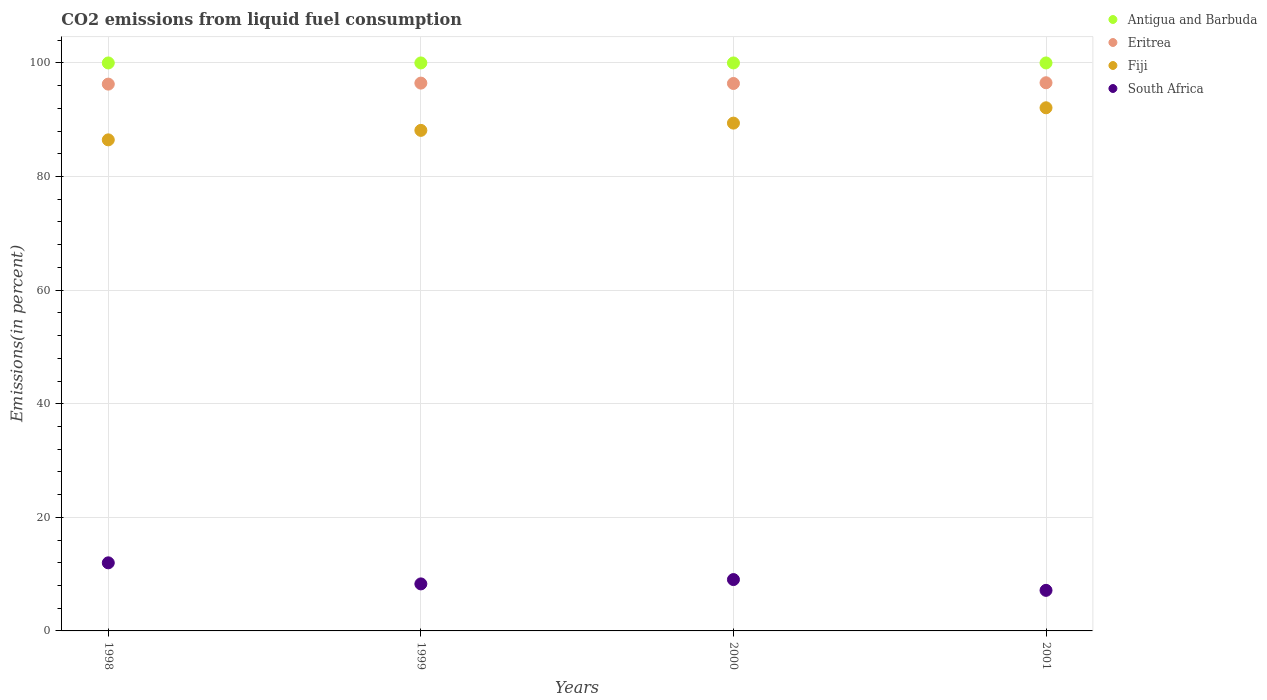Is the number of dotlines equal to the number of legend labels?
Make the answer very short. Yes. What is the total CO2 emitted in South Africa in 2000?
Your answer should be compact. 9.04. Across all years, what is the maximum total CO2 emitted in Antigua and Barbuda?
Your response must be concise. 100. Across all years, what is the minimum total CO2 emitted in Eritrea?
Give a very brief answer. 96.27. In which year was the total CO2 emitted in Eritrea maximum?
Keep it short and to the point. 2001. What is the total total CO2 emitted in Antigua and Barbuda in the graph?
Your answer should be very brief. 400. What is the difference between the total CO2 emitted in Antigua and Barbuda in 1998 and that in 2001?
Provide a short and direct response. 0. What is the difference between the total CO2 emitted in Eritrea in 1998 and the total CO2 emitted in Fiji in 1999?
Provide a succinct answer. 8.15. What is the average total CO2 emitted in Eritrea per year?
Your answer should be very brief. 96.41. In the year 2000, what is the difference between the total CO2 emitted in Eritrea and total CO2 emitted in Antigua and Barbuda?
Your response must be concise. -3.61. In how many years, is the total CO2 emitted in Fiji greater than 88 %?
Your answer should be compact. 3. What is the ratio of the total CO2 emitted in Eritrea in 1998 to that in 2000?
Make the answer very short. 1. What is the difference between the highest and the second highest total CO2 emitted in Fiji?
Make the answer very short. 2.7. In how many years, is the total CO2 emitted in Fiji greater than the average total CO2 emitted in Fiji taken over all years?
Your answer should be very brief. 2. Does the total CO2 emitted in Antigua and Barbuda monotonically increase over the years?
Provide a succinct answer. No. How many years are there in the graph?
Your answer should be compact. 4. Does the graph contain any zero values?
Your response must be concise. No. Does the graph contain grids?
Give a very brief answer. Yes. Where does the legend appear in the graph?
Keep it short and to the point. Top right. How many legend labels are there?
Provide a short and direct response. 4. What is the title of the graph?
Provide a succinct answer. CO2 emissions from liquid fuel consumption. Does "Korea (Republic)" appear as one of the legend labels in the graph?
Your response must be concise. No. What is the label or title of the Y-axis?
Your response must be concise. Emissions(in percent). What is the Emissions(in percent) in Antigua and Barbuda in 1998?
Offer a very short reply. 100. What is the Emissions(in percent) of Eritrea in 1998?
Ensure brevity in your answer.  96.27. What is the Emissions(in percent) in Fiji in 1998?
Give a very brief answer. 86.46. What is the Emissions(in percent) in South Africa in 1998?
Offer a terse response. 11.99. What is the Emissions(in percent) in Antigua and Barbuda in 1999?
Provide a succinct answer. 100. What is the Emissions(in percent) in Eritrea in 1999?
Ensure brevity in your answer.  96.45. What is the Emissions(in percent) of Fiji in 1999?
Your response must be concise. 88.13. What is the Emissions(in percent) in South Africa in 1999?
Your answer should be very brief. 8.28. What is the Emissions(in percent) of Eritrea in 2000?
Offer a very short reply. 96.39. What is the Emissions(in percent) in Fiji in 2000?
Offer a very short reply. 89.41. What is the Emissions(in percent) of South Africa in 2000?
Provide a short and direct response. 9.04. What is the Emissions(in percent) of Antigua and Barbuda in 2001?
Ensure brevity in your answer.  100. What is the Emissions(in percent) in Eritrea in 2001?
Ensure brevity in your answer.  96.51. What is the Emissions(in percent) in Fiji in 2001?
Provide a succinct answer. 92.11. What is the Emissions(in percent) in South Africa in 2001?
Ensure brevity in your answer.  7.14. Across all years, what is the maximum Emissions(in percent) in Eritrea?
Make the answer very short. 96.51. Across all years, what is the maximum Emissions(in percent) in Fiji?
Provide a succinct answer. 92.11. Across all years, what is the maximum Emissions(in percent) in South Africa?
Provide a succinct answer. 11.99. Across all years, what is the minimum Emissions(in percent) of Eritrea?
Provide a succinct answer. 96.27. Across all years, what is the minimum Emissions(in percent) in Fiji?
Ensure brevity in your answer.  86.46. Across all years, what is the minimum Emissions(in percent) of South Africa?
Give a very brief answer. 7.14. What is the total Emissions(in percent) of Antigua and Barbuda in the graph?
Provide a short and direct response. 400. What is the total Emissions(in percent) of Eritrea in the graph?
Offer a terse response. 385.62. What is the total Emissions(in percent) in Fiji in the graph?
Give a very brief answer. 356.1. What is the total Emissions(in percent) of South Africa in the graph?
Your response must be concise. 36.45. What is the difference between the Emissions(in percent) of Eritrea in 1998 and that in 1999?
Offer a very short reply. -0.18. What is the difference between the Emissions(in percent) in Fiji in 1998 and that in 1999?
Make the answer very short. -1.67. What is the difference between the Emissions(in percent) of South Africa in 1998 and that in 1999?
Your response must be concise. 3.71. What is the difference between the Emissions(in percent) in Antigua and Barbuda in 1998 and that in 2000?
Give a very brief answer. 0. What is the difference between the Emissions(in percent) in Eritrea in 1998 and that in 2000?
Your answer should be compact. -0.11. What is the difference between the Emissions(in percent) in Fiji in 1998 and that in 2000?
Keep it short and to the point. -2.95. What is the difference between the Emissions(in percent) in South Africa in 1998 and that in 2000?
Your response must be concise. 2.95. What is the difference between the Emissions(in percent) in Antigua and Barbuda in 1998 and that in 2001?
Your answer should be compact. 0. What is the difference between the Emissions(in percent) of Eritrea in 1998 and that in 2001?
Your answer should be very brief. -0.24. What is the difference between the Emissions(in percent) of Fiji in 1998 and that in 2001?
Your answer should be very brief. -5.65. What is the difference between the Emissions(in percent) in South Africa in 1998 and that in 2001?
Your answer should be compact. 4.85. What is the difference between the Emissions(in percent) of Antigua and Barbuda in 1999 and that in 2000?
Give a very brief answer. 0. What is the difference between the Emissions(in percent) in Eritrea in 1999 and that in 2000?
Give a very brief answer. 0.06. What is the difference between the Emissions(in percent) in Fiji in 1999 and that in 2000?
Offer a terse response. -1.28. What is the difference between the Emissions(in percent) of South Africa in 1999 and that in 2000?
Your answer should be very brief. -0.76. What is the difference between the Emissions(in percent) in Antigua and Barbuda in 1999 and that in 2001?
Provide a short and direct response. 0. What is the difference between the Emissions(in percent) of Eritrea in 1999 and that in 2001?
Provide a succinct answer. -0.06. What is the difference between the Emissions(in percent) of Fiji in 1999 and that in 2001?
Offer a terse response. -3.98. What is the difference between the Emissions(in percent) in South Africa in 1999 and that in 2001?
Give a very brief answer. 1.14. What is the difference between the Emissions(in percent) in Antigua and Barbuda in 2000 and that in 2001?
Ensure brevity in your answer.  0. What is the difference between the Emissions(in percent) of Eritrea in 2000 and that in 2001?
Your response must be concise. -0.13. What is the difference between the Emissions(in percent) of Fiji in 2000 and that in 2001?
Keep it short and to the point. -2.7. What is the difference between the Emissions(in percent) of South Africa in 2000 and that in 2001?
Give a very brief answer. 1.9. What is the difference between the Emissions(in percent) in Antigua and Barbuda in 1998 and the Emissions(in percent) in Eritrea in 1999?
Your answer should be compact. 3.55. What is the difference between the Emissions(in percent) of Antigua and Barbuda in 1998 and the Emissions(in percent) of Fiji in 1999?
Keep it short and to the point. 11.87. What is the difference between the Emissions(in percent) of Antigua and Barbuda in 1998 and the Emissions(in percent) of South Africa in 1999?
Ensure brevity in your answer.  91.72. What is the difference between the Emissions(in percent) of Eritrea in 1998 and the Emissions(in percent) of Fiji in 1999?
Ensure brevity in your answer.  8.15. What is the difference between the Emissions(in percent) in Eritrea in 1998 and the Emissions(in percent) in South Africa in 1999?
Provide a succinct answer. 88. What is the difference between the Emissions(in percent) of Fiji in 1998 and the Emissions(in percent) of South Africa in 1999?
Provide a short and direct response. 78.18. What is the difference between the Emissions(in percent) of Antigua and Barbuda in 1998 and the Emissions(in percent) of Eritrea in 2000?
Give a very brief answer. 3.61. What is the difference between the Emissions(in percent) of Antigua and Barbuda in 1998 and the Emissions(in percent) of Fiji in 2000?
Provide a short and direct response. 10.59. What is the difference between the Emissions(in percent) of Antigua and Barbuda in 1998 and the Emissions(in percent) of South Africa in 2000?
Provide a short and direct response. 90.96. What is the difference between the Emissions(in percent) in Eritrea in 1998 and the Emissions(in percent) in Fiji in 2000?
Ensure brevity in your answer.  6.87. What is the difference between the Emissions(in percent) in Eritrea in 1998 and the Emissions(in percent) in South Africa in 2000?
Make the answer very short. 87.23. What is the difference between the Emissions(in percent) of Fiji in 1998 and the Emissions(in percent) of South Africa in 2000?
Give a very brief answer. 77.42. What is the difference between the Emissions(in percent) of Antigua and Barbuda in 1998 and the Emissions(in percent) of Eritrea in 2001?
Your response must be concise. 3.49. What is the difference between the Emissions(in percent) in Antigua and Barbuda in 1998 and the Emissions(in percent) in Fiji in 2001?
Offer a very short reply. 7.89. What is the difference between the Emissions(in percent) in Antigua and Barbuda in 1998 and the Emissions(in percent) in South Africa in 2001?
Your response must be concise. 92.86. What is the difference between the Emissions(in percent) in Eritrea in 1998 and the Emissions(in percent) in Fiji in 2001?
Offer a very short reply. 4.17. What is the difference between the Emissions(in percent) of Eritrea in 1998 and the Emissions(in percent) of South Africa in 2001?
Make the answer very short. 89.13. What is the difference between the Emissions(in percent) of Fiji in 1998 and the Emissions(in percent) of South Africa in 2001?
Give a very brief answer. 79.32. What is the difference between the Emissions(in percent) of Antigua and Barbuda in 1999 and the Emissions(in percent) of Eritrea in 2000?
Offer a terse response. 3.61. What is the difference between the Emissions(in percent) of Antigua and Barbuda in 1999 and the Emissions(in percent) of Fiji in 2000?
Provide a succinct answer. 10.59. What is the difference between the Emissions(in percent) of Antigua and Barbuda in 1999 and the Emissions(in percent) of South Africa in 2000?
Your response must be concise. 90.96. What is the difference between the Emissions(in percent) in Eritrea in 1999 and the Emissions(in percent) in Fiji in 2000?
Give a very brief answer. 7.04. What is the difference between the Emissions(in percent) in Eritrea in 1999 and the Emissions(in percent) in South Africa in 2000?
Provide a short and direct response. 87.41. What is the difference between the Emissions(in percent) in Fiji in 1999 and the Emissions(in percent) in South Africa in 2000?
Your answer should be compact. 79.09. What is the difference between the Emissions(in percent) in Antigua and Barbuda in 1999 and the Emissions(in percent) in Eritrea in 2001?
Offer a terse response. 3.49. What is the difference between the Emissions(in percent) of Antigua and Barbuda in 1999 and the Emissions(in percent) of Fiji in 2001?
Offer a terse response. 7.89. What is the difference between the Emissions(in percent) in Antigua and Barbuda in 1999 and the Emissions(in percent) in South Africa in 2001?
Provide a succinct answer. 92.86. What is the difference between the Emissions(in percent) in Eritrea in 1999 and the Emissions(in percent) in Fiji in 2001?
Provide a succinct answer. 4.34. What is the difference between the Emissions(in percent) of Eritrea in 1999 and the Emissions(in percent) of South Africa in 2001?
Provide a succinct answer. 89.31. What is the difference between the Emissions(in percent) of Fiji in 1999 and the Emissions(in percent) of South Africa in 2001?
Your answer should be compact. 80.99. What is the difference between the Emissions(in percent) of Antigua and Barbuda in 2000 and the Emissions(in percent) of Eritrea in 2001?
Provide a short and direct response. 3.49. What is the difference between the Emissions(in percent) in Antigua and Barbuda in 2000 and the Emissions(in percent) in Fiji in 2001?
Make the answer very short. 7.89. What is the difference between the Emissions(in percent) of Antigua and Barbuda in 2000 and the Emissions(in percent) of South Africa in 2001?
Give a very brief answer. 92.86. What is the difference between the Emissions(in percent) in Eritrea in 2000 and the Emissions(in percent) in Fiji in 2001?
Offer a terse response. 4.28. What is the difference between the Emissions(in percent) in Eritrea in 2000 and the Emissions(in percent) in South Africa in 2001?
Give a very brief answer. 89.24. What is the difference between the Emissions(in percent) in Fiji in 2000 and the Emissions(in percent) in South Africa in 2001?
Provide a short and direct response. 82.26. What is the average Emissions(in percent) of Antigua and Barbuda per year?
Your answer should be very brief. 100. What is the average Emissions(in percent) in Eritrea per year?
Make the answer very short. 96.41. What is the average Emissions(in percent) in Fiji per year?
Provide a short and direct response. 89.02. What is the average Emissions(in percent) of South Africa per year?
Your answer should be very brief. 9.11. In the year 1998, what is the difference between the Emissions(in percent) of Antigua and Barbuda and Emissions(in percent) of Eritrea?
Your answer should be very brief. 3.73. In the year 1998, what is the difference between the Emissions(in percent) in Antigua and Barbuda and Emissions(in percent) in Fiji?
Ensure brevity in your answer.  13.54. In the year 1998, what is the difference between the Emissions(in percent) of Antigua and Barbuda and Emissions(in percent) of South Africa?
Keep it short and to the point. 88.01. In the year 1998, what is the difference between the Emissions(in percent) in Eritrea and Emissions(in percent) in Fiji?
Ensure brevity in your answer.  9.81. In the year 1998, what is the difference between the Emissions(in percent) of Eritrea and Emissions(in percent) of South Africa?
Provide a succinct answer. 84.28. In the year 1998, what is the difference between the Emissions(in percent) in Fiji and Emissions(in percent) in South Africa?
Provide a short and direct response. 74.47. In the year 1999, what is the difference between the Emissions(in percent) in Antigua and Barbuda and Emissions(in percent) in Eritrea?
Your response must be concise. 3.55. In the year 1999, what is the difference between the Emissions(in percent) of Antigua and Barbuda and Emissions(in percent) of Fiji?
Give a very brief answer. 11.87. In the year 1999, what is the difference between the Emissions(in percent) of Antigua and Barbuda and Emissions(in percent) of South Africa?
Keep it short and to the point. 91.72. In the year 1999, what is the difference between the Emissions(in percent) in Eritrea and Emissions(in percent) in Fiji?
Offer a very short reply. 8.32. In the year 1999, what is the difference between the Emissions(in percent) in Eritrea and Emissions(in percent) in South Africa?
Make the answer very short. 88.17. In the year 1999, what is the difference between the Emissions(in percent) in Fiji and Emissions(in percent) in South Africa?
Offer a terse response. 79.85. In the year 2000, what is the difference between the Emissions(in percent) in Antigua and Barbuda and Emissions(in percent) in Eritrea?
Make the answer very short. 3.61. In the year 2000, what is the difference between the Emissions(in percent) of Antigua and Barbuda and Emissions(in percent) of Fiji?
Give a very brief answer. 10.59. In the year 2000, what is the difference between the Emissions(in percent) of Antigua and Barbuda and Emissions(in percent) of South Africa?
Your answer should be compact. 90.96. In the year 2000, what is the difference between the Emissions(in percent) in Eritrea and Emissions(in percent) in Fiji?
Keep it short and to the point. 6.98. In the year 2000, what is the difference between the Emissions(in percent) of Eritrea and Emissions(in percent) of South Africa?
Your answer should be compact. 87.34. In the year 2000, what is the difference between the Emissions(in percent) of Fiji and Emissions(in percent) of South Africa?
Your answer should be very brief. 80.36. In the year 2001, what is the difference between the Emissions(in percent) of Antigua and Barbuda and Emissions(in percent) of Eritrea?
Provide a succinct answer. 3.49. In the year 2001, what is the difference between the Emissions(in percent) of Antigua and Barbuda and Emissions(in percent) of Fiji?
Ensure brevity in your answer.  7.89. In the year 2001, what is the difference between the Emissions(in percent) in Antigua and Barbuda and Emissions(in percent) in South Africa?
Make the answer very short. 92.86. In the year 2001, what is the difference between the Emissions(in percent) in Eritrea and Emissions(in percent) in Fiji?
Provide a short and direct response. 4.41. In the year 2001, what is the difference between the Emissions(in percent) in Eritrea and Emissions(in percent) in South Africa?
Keep it short and to the point. 89.37. In the year 2001, what is the difference between the Emissions(in percent) in Fiji and Emissions(in percent) in South Africa?
Offer a very short reply. 84.96. What is the ratio of the Emissions(in percent) in Antigua and Barbuda in 1998 to that in 1999?
Offer a terse response. 1. What is the ratio of the Emissions(in percent) of Eritrea in 1998 to that in 1999?
Give a very brief answer. 1. What is the ratio of the Emissions(in percent) of Fiji in 1998 to that in 1999?
Give a very brief answer. 0.98. What is the ratio of the Emissions(in percent) of South Africa in 1998 to that in 1999?
Provide a short and direct response. 1.45. What is the ratio of the Emissions(in percent) in Antigua and Barbuda in 1998 to that in 2000?
Ensure brevity in your answer.  1. What is the ratio of the Emissions(in percent) of South Africa in 1998 to that in 2000?
Your response must be concise. 1.33. What is the ratio of the Emissions(in percent) in Eritrea in 1998 to that in 2001?
Provide a short and direct response. 1. What is the ratio of the Emissions(in percent) of Fiji in 1998 to that in 2001?
Provide a short and direct response. 0.94. What is the ratio of the Emissions(in percent) in South Africa in 1998 to that in 2001?
Make the answer very short. 1.68. What is the ratio of the Emissions(in percent) of Antigua and Barbuda in 1999 to that in 2000?
Give a very brief answer. 1. What is the ratio of the Emissions(in percent) of Eritrea in 1999 to that in 2000?
Offer a terse response. 1. What is the ratio of the Emissions(in percent) of Fiji in 1999 to that in 2000?
Your answer should be compact. 0.99. What is the ratio of the Emissions(in percent) in South Africa in 1999 to that in 2000?
Give a very brief answer. 0.92. What is the ratio of the Emissions(in percent) of Antigua and Barbuda in 1999 to that in 2001?
Keep it short and to the point. 1. What is the ratio of the Emissions(in percent) in Fiji in 1999 to that in 2001?
Offer a very short reply. 0.96. What is the ratio of the Emissions(in percent) of South Africa in 1999 to that in 2001?
Your response must be concise. 1.16. What is the ratio of the Emissions(in percent) in Fiji in 2000 to that in 2001?
Offer a terse response. 0.97. What is the ratio of the Emissions(in percent) in South Africa in 2000 to that in 2001?
Your answer should be very brief. 1.27. What is the difference between the highest and the second highest Emissions(in percent) of Eritrea?
Provide a succinct answer. 0.06. What is the difference between the highest and the second highest Emissions(in percent) in Fiji?
Provide a succinct answer. 2.7. What is the difference between the highest and the second highest Emissions(in percent) of South Africa?
Your answer should be compact. 2.95. What is the difference between the highest and the lowest Emissions(in percent) of Eritrea?
Keep it short and to the point. 0.24. What is the difference between the highest and the lowest Emissions(in percent) of Fiji?
Ensure brevity in your answer.  5.65. What is the difference between the highest and the lowest Emissions(in percent) of South Africa?
Keep it short and to the point. 4.85. 